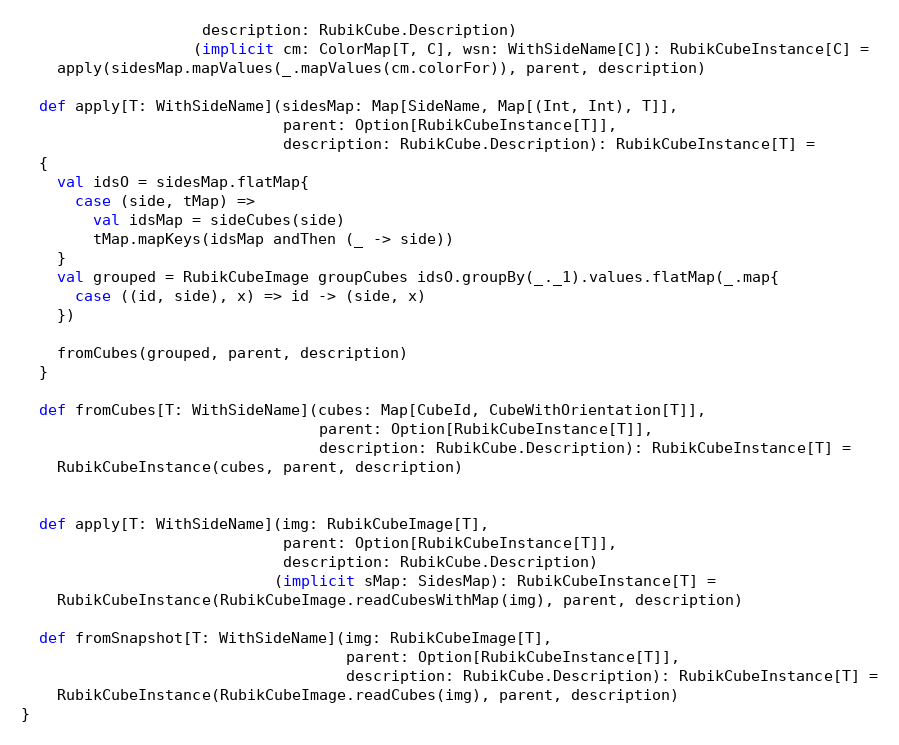<code> <loc_0><loc_0><loc_500><loc_500><_Scala_>                    description: RubikCube.Description)
                   (implicit cm: ColorMap[T, C], wsn: WithSideName[C]): RubikCubeInstance[C] =
    apply(sidesMap.mapValues(_.mapValues(cm.colorFor)), parent, description)

  def apply[T: WithSideName](sidesMap: Map[SideName, Map[(Int, Int), T]],
                             parent: Option[RubikCubeInstance[T]],
                             description: RubikCube.Description): RubikCubeInstance[T] =
  {
    val idsO = sidesMap.flatMap{
      case (side, tMap) =>
        val idsMap = sideCubes(side)
        tMap.mapKeys(idsMap andThen (_ -> side))
    }
    val grouped = RubikCubeImage groupCubes idsO.groupBy(_._1).values.flatMap(_.map{
      case ((id, side), x) => id -> (side, x)
    })

    fromCubes(grouped, parent, description)
  }

  def fromCubes[T: WithSideName](cubes: Map[CubeId, CubeWithOrientation[T]],
                                 parent: Option[RubikCubeInstance[T]],
                                 description: RubikCube.Description): RubikCubeInstance[T] =
    RubikCubeInstance(cubes, parent, description)


  def apply[T: WithSideName](img: RubikCubeImage[T],
                             parent: Option[RubikCubeInstance[T]],
                             description: RubikCube.Description)
                            (implicit sMap: SidesMap): RubikCubeInstance[T] =
    RubikCubeInstance(RubikCubeImage.readCubesWithMap(img), parent, description)

  def fromSnapshot[T: WithSideName](img: RubikCubeImage[T],
                                    parent: Option[RubikCubeInstance[T]],
                                    description: RubikCube.Description): RubikCubeInstance[T] =
    RubikCubeInstance(RubikCubeImage.readCubes(img), parent, description)
}</code> 